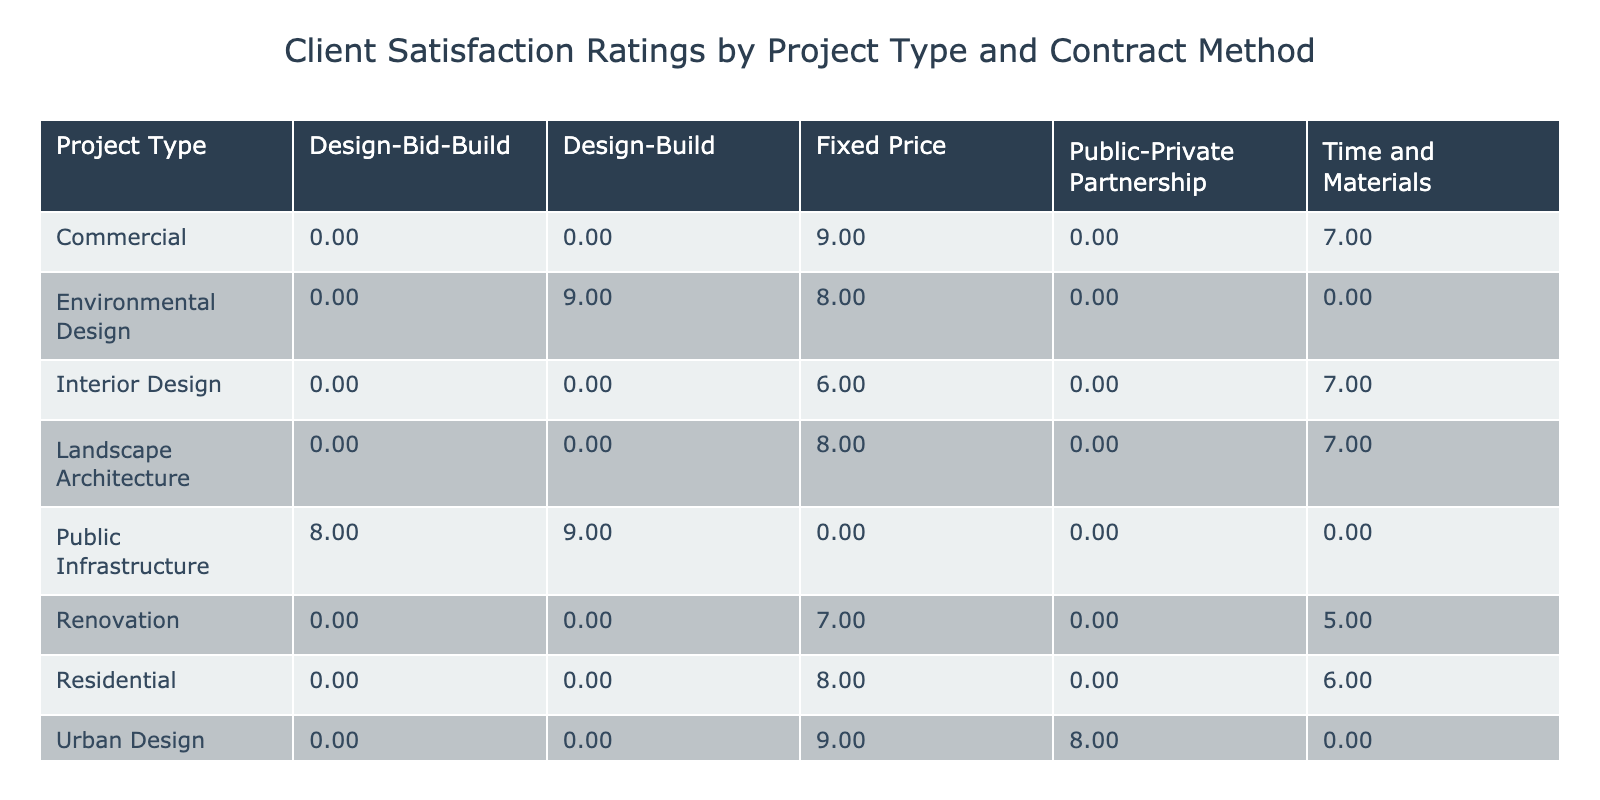What is the client satisfaction rating for Public Infrastructure using the Design-Bid-Build contract method? Referring to the table, the rating for Public Infrastructure with the Design-Bid-Build method is directly listed under that contract method. It shows a satisfaction rating of 8.
Answer: 8 What are the client satisfaction ratings for Residential projects using both contract methods? The table lists the satisfaction ratings for Residential projects: Fixed Price shows a rating of 8, while Time and Materials shows a rating of 6.
Answer: 8 (Fixed Price), 6 (Time and Materials) Is the average client satisfaction rating for Commercial projects higher than that for Renovation projects? The average for Commercial projects (mean of 9 and 7) is (9 + 7) / 2 = 8, while the average for Renovation (mean of 7 and 5) is (7 + 5) / 2 = 6. Thus, 8 is indeed higher than 6.
Answer: Yes What is the satisfaction rating difference between Landscape Architecture and Interior Design using Fixed Price? For Landscape Architecture, the Fixed Price rating is 8, and for Interior Design, it is 6. The difference is 8 - 6 = 2.
Answer: 2 Do all project types show a satisfaction rating of at least 5? Looking at the table, every project type has ratings listed. The lowest rating is 5 (for Renovation with Time and Materials), confirming that all project types have ratings of at least 5.
Answer: Yes Which contract method has the highest client satisfaction rating overall, and what is that rating? To determine this, we check the highest ratings across all contract methods. The highest is 9, found under Fixed Price for both Commercial and Environmental Design.
Answer: Fixed Price, 9 How does the client satisfaction rating for Urban Design compare to that of Environmental Design using the Fixed Price method? Urban Design with Fixed Price has a rating of 9 and Environmental Design has a rating of 8. When comparing these, Urban Design is higher.
Answer: Urban Design is higher What is the satisfaction rating for Time and Materials in Renovation projects? The table indicates that the rating for Renovation using the Time and Materials method is specifically listed as 5.
Answer: 5 